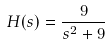Convert formula to latex. <formula><loc_0><loc_0><loc_500><loc_500>H ( s ) = \frac { 9 } { s ^ { 2 } + 9 }</formula> 